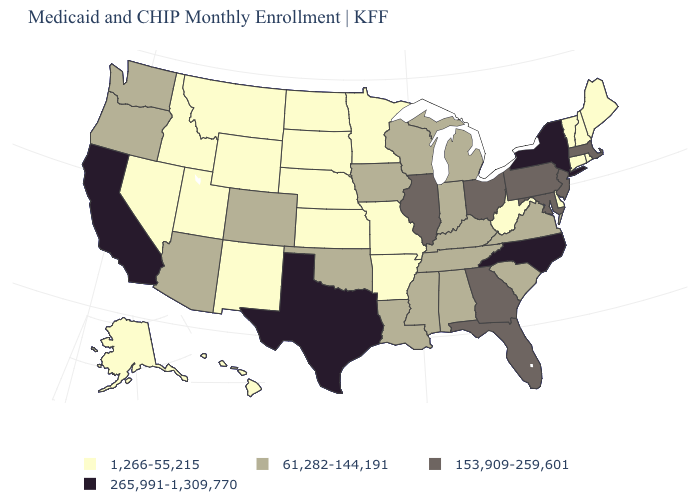What is the highest value in states that border Texas?
Short answer required. 61,282-144,191. What is the value of Oregon?
Short answer required. 61,282-144,191. Which states have the lowest value in the USA?
Answer briefly. Alaska, Arkansas, Connecticut, Delaware, Hawaii, Idaho, Kansas, Maine, Minnesota, Missouri, Montana, Nebraska, Nevada, New Hampshire, New Mexico, North Dakota, Rhode Island, South Dakota, Utah, Vermont, West Virginia, Wyoming. What is the value of Alaska?
Quick response, please. 1,266-55,215. Does South Dakota have a lower value than Alaska?
Give a very brief answer. No. What is the highest value in the MidWest ?
Quick response, please. 153,909-259,601. What is the value of Virginia?
Write a very short answer. 61,282-144,191. What is the highest value in the West ?
Answer briefly. 265,991-1,309,770. Does the map have missing data?
Quick response, please. No. What is the value of California?
Write a very short answer. 265,991-1,309,770. Does New Hampshire have the highest value in the Northeast?
Give a very brief answer. No. What is the value of New Mexico?
Concise answer only. 1,266-55,215. Name the states that have a value in the range 153,909-259,601?
Quick response, please. Florida, Georgia, Illinois, Maryland, Massachusetts, New Jersey, Ohio, Pennsylvania. Which states have the highest value in the USA?
Quick response, please. California, New York, North Carolina, Texas. What is the lowest value in the Northeast?
Concise answer only. 1,266-55,215. 